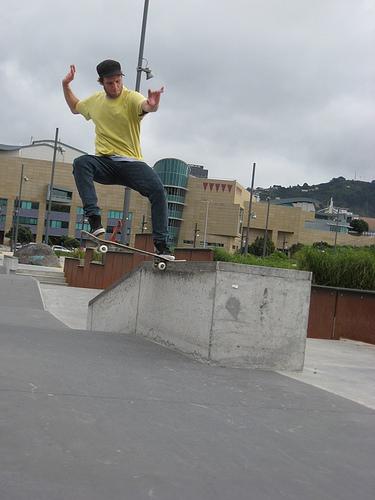What color is the skater's hat?
Short answer required. Black. Is this Busch Stadium?
Write a very short answer. No. Is the person wearing a helmet?
Write a very short answer. No. What is the boy doing?
Answer briefly. Skateboarding. What color shirt is the subject wearing?
Quick response, please. Yellow. Is this called "Hanging Ten"?
Short answer required. No. Is the skater doing a trick?
Keep it brief. Yes. Is his t-shirt tucked in?
Keep it brief. No. 